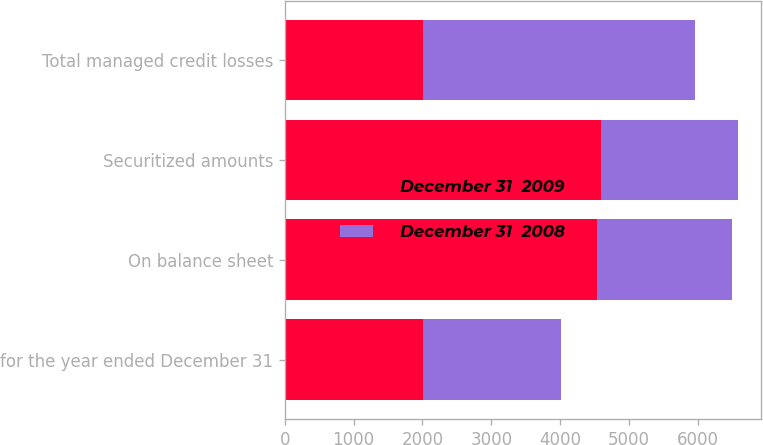Convert chart. <chart><loc_0><loc_0><loc_500><loc_500><stacked_bar_chart><ecel><fcel>for the year ended December 31<fcel>On balance sheet<fcel>Securitized amounts<fcel>Total managed credit losses<nl><fcel>December 31  2009<fcel>2009<fcel>4540<fcel>4590<fcel>2009<nl><fcel>December 31  2008<fcel>2007<fcel>1956<fcel>1995<fcel>3951<nl></chart> 